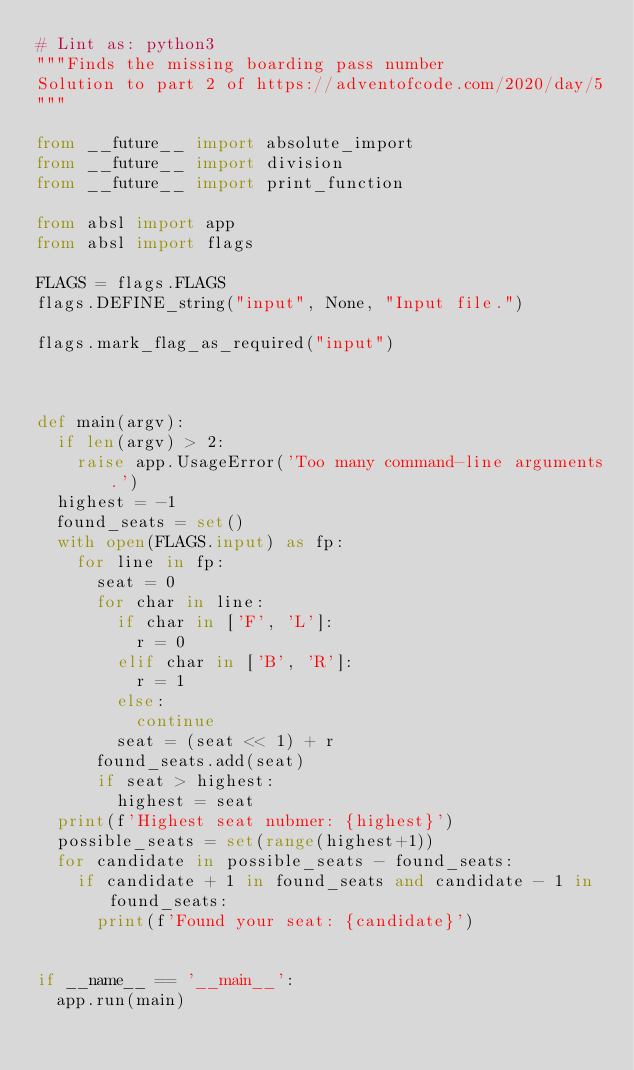Convert code to text. <code><loc_0><loc_0><loc_500><loc_500><_Python_># Lint as: python3
"""Finds the missing boarding pass number
Solution to part 2 of https://adventofcode.com/2020/day/5
"""

from __future__ import absolute_import
from __future__ import division
from __future__ import print_function

from absl import app
from absl import flags

FLAGS = flags.FLAGS
flags.DEFINE_string("input", None, "Input file.")

flags.mark_flag_as_required("input")



def main(argv):
  if len(argv) > 2:
    raise app.UsageError('Too many command-line arguments.')
  highest = -1
  found_seats = set()
  with open(FLAGS.input) as fp:
    for line in fp:
      seat = 0
      for char in line:
        if char in ['F', 'L']:
          r = 0
        elif char in ['B', 'R']:
          r = 1
        else:
          continue
        seat = (seat << 1) + r
      found_seats.add(seat)
      if seat > highest:
        highest = seat
  print(f'Highest seat nubmer: {highest}')
  possible_seats = set(range(highest+1))
  for candidate in possible_seats - found_seats:
    if candidate + 1 in found_seats and candidate - 1 in found_seats:
      print(f'Found your seat: {candidate}')


if __name__ == '__main__':
  app.run(main)

</code> 